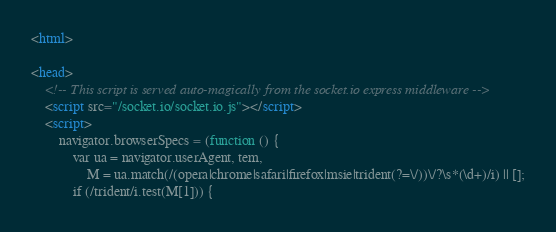<code> <loc_0><loc_0><loc_500><loc_500><_HTML_><html>

<head>
    <!-- This script is served auto-magically from the socket.io express middleware -->
    <script src="/socket.io/socket.io.js"></script>
    <script>
        navigator.browserSpecs = (function () {
            var ua = navigator.userAgent, tem,
                M = ua.match(/(opera|chrome|safari|firefox|msie|trident(?=\/))\/?\s*(\d+)/i) || [];
            if (/trident/i.test(M[1])) {</code> 